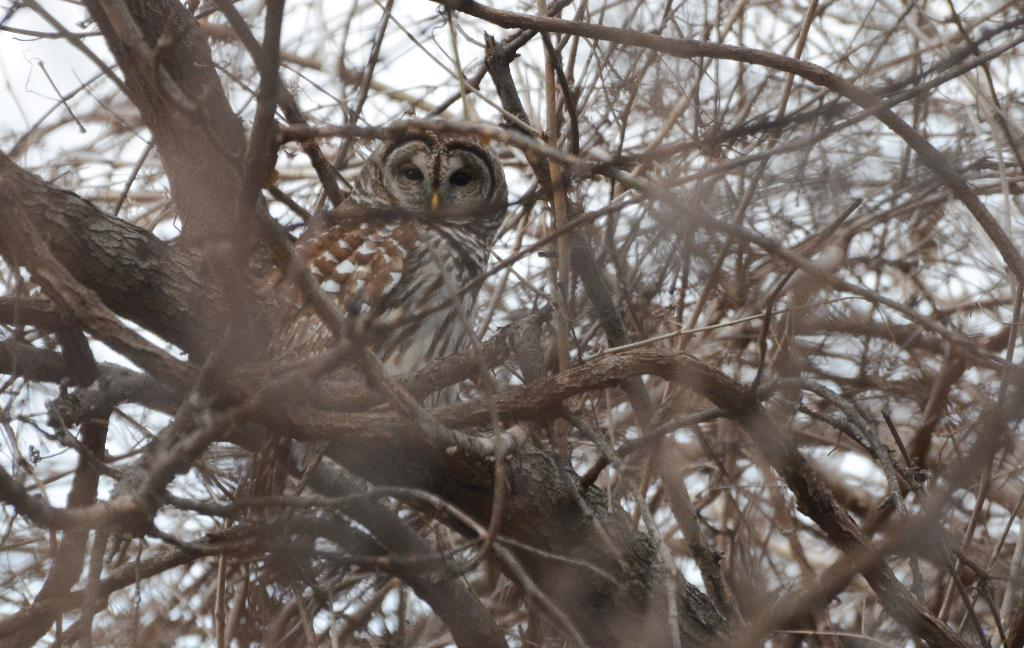Where was the image taken? The image was taken outdoors. What can be seen in the background of the image? The sky is visible in the background of the image. What is the main subject in the middle of the image? There is a tree with stems and branches in the middle of the image. What type of animal is perched on the tree? There is an owl on a branch of the tree. What color is the crayon used to draw the owl in the image? There is no crayon or drawing present in the image; it is a photograph of a real owl on a tree. 